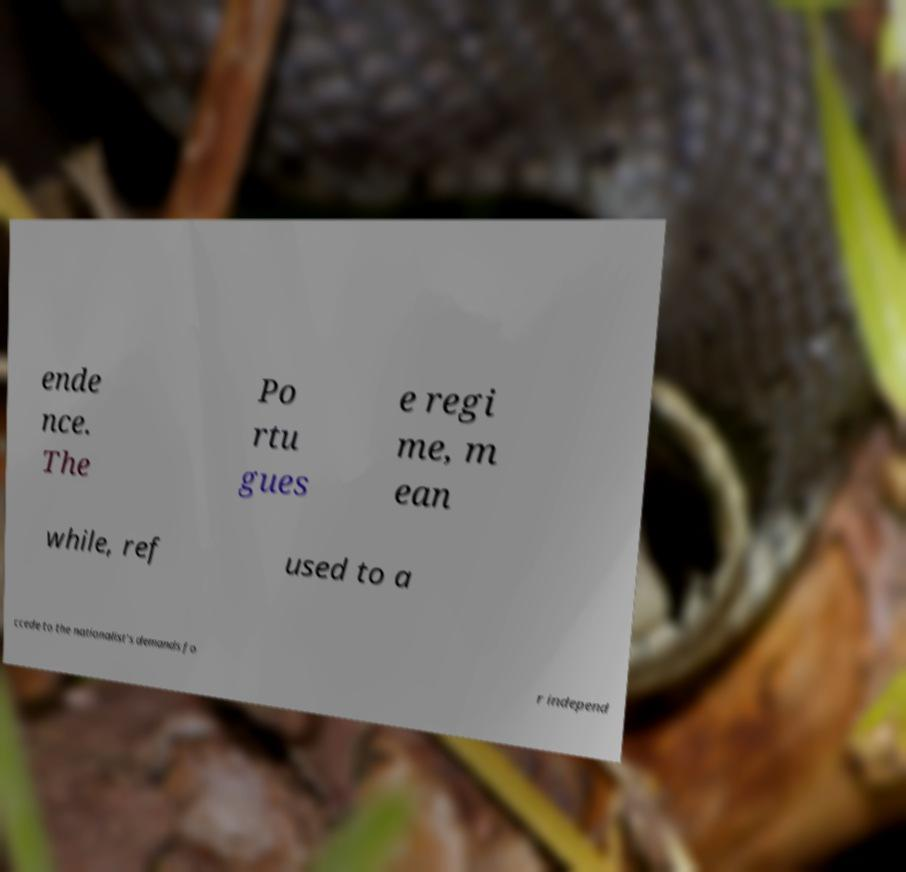Could you extract and type out the text from this image? ende nce. The Po rtu gues e regi me, m ean while, ref used to a ccede to the nationalist's demands fo r independ 